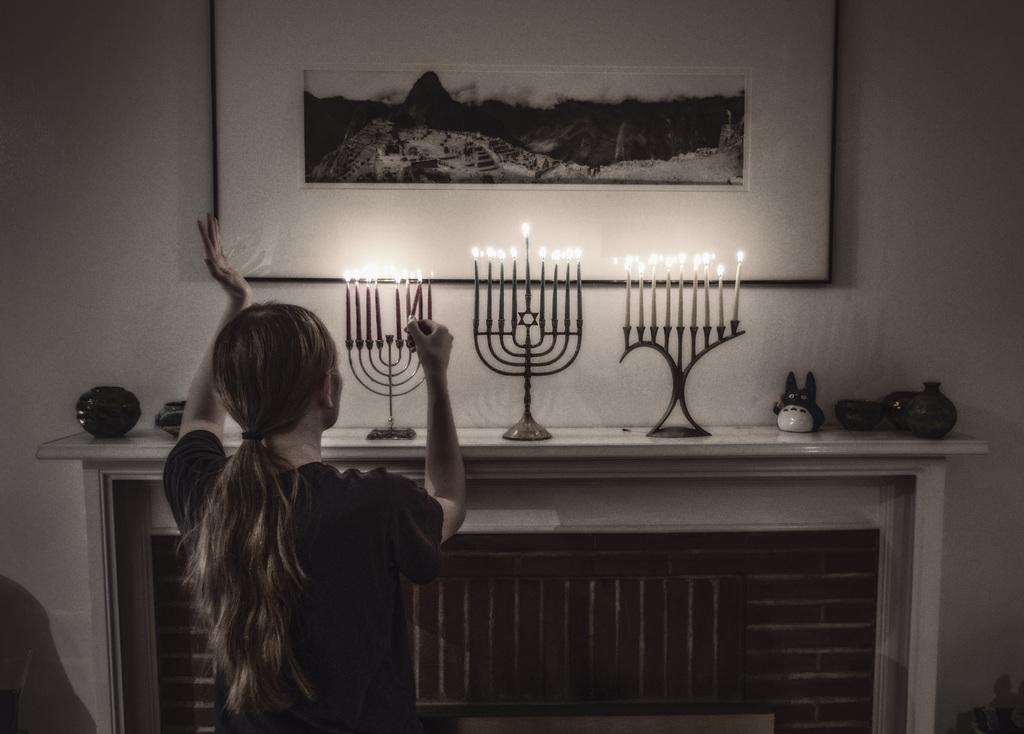Who is present in the image? There is a woman in the image. What is the woman wearing? The woman is wearing clothes. What objects can be seen in the image? There are candles, stands, a brick wall, and a frame visible. What type of wall is present in the image? There is a brick wall and a white wall in the image. What type of cheese is being served on the table in the image? There is no table or cheese present in the image. How many cattle can be seen grazing in the background of the image? There are no cattle present in the image. 